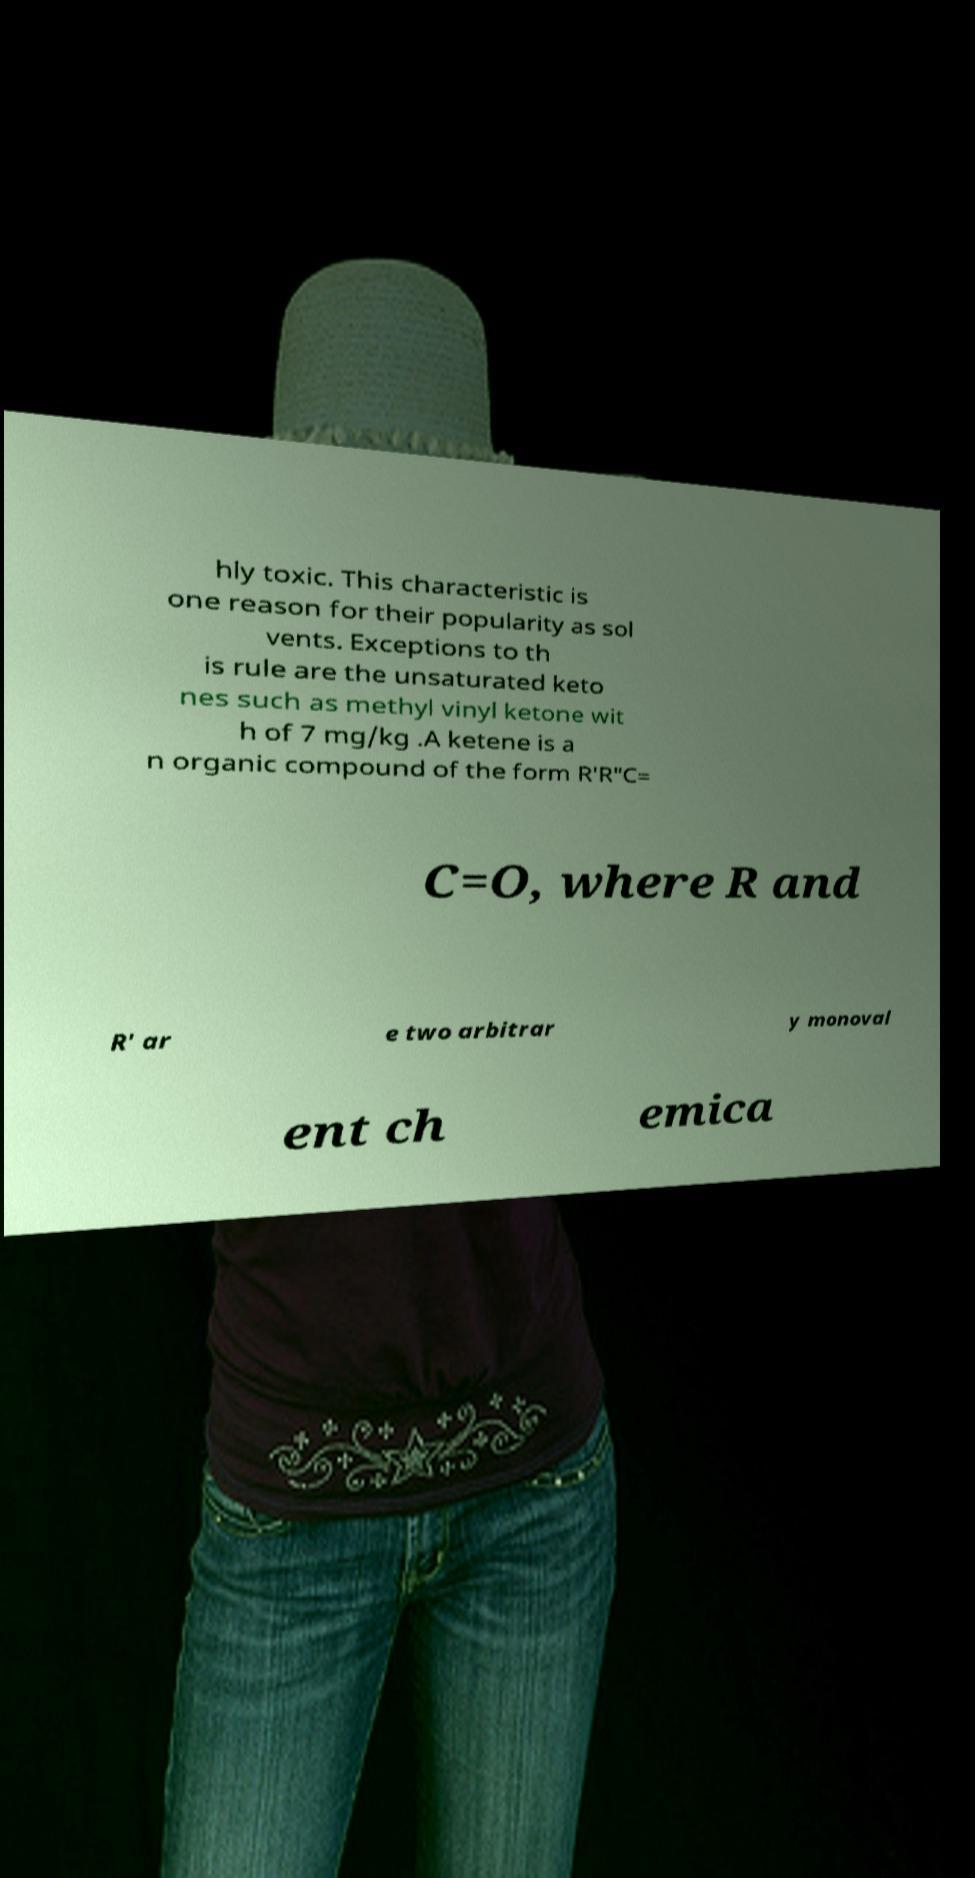Could you assist in decoding the text presented in this image and type it out clearly? hly toxic. This characteristic is one reason for their popularity as sol vents. Exceptions to th is rule are the unsaturated keto nes such as methyl vinyl ketone wit h of 7 mg/kg .A ketene is a n organic compound of the form R′R″C= C=O, where R and R' ar e two arbitrar y monoval ent ch emica 